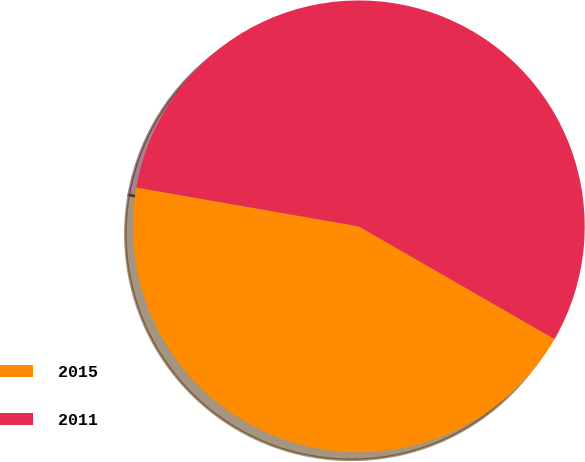Convert chart. <chart><loc_0><loc_0><loc_500><loc_500><pie_chart><fcel>2015<fcel>2011<nl><fcel>44.44%<fcel>55.56%<nl></chart> 